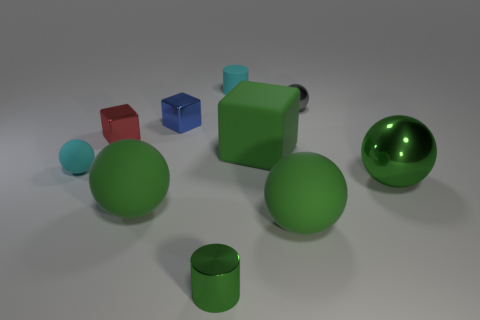How many objects are small objects that are left of the tiny gray shiny ball or things that are to the left of the big shiny sphere?
Your answer should be very brief. 9. Is there anything else that is the same shape as the tiny blue thing?
Provide a succinct answer. Yes. What number of cyan objects are there?
Ensure brevity in your answer.  2. Are there any gray matte spheres of the same size as the gray thing?
Ensure brevity in your answer.  No. Do the small red object and the small block that is to the right of the tiny red cube have the same material?
Offer a terse response. Yes. What material is the large object that is right of the small gray sphere?
Your answer should be very brief. Metal. The red thing has what size?
Offer a very short reply. Small. There is a rubber ball on the right side of the cyan cylinder; does it have the same size as the gray metal sphere that is behind the green metallic cylinder?
Your answer should be compact. No. What size is the cyan matte thing that is the same shape as the tiny green object?
Offer a terse response. Small. Is the size of the cyan ball the same as the green rubber ball that is right of the small blue object?
Keep it short and to the point. No. 